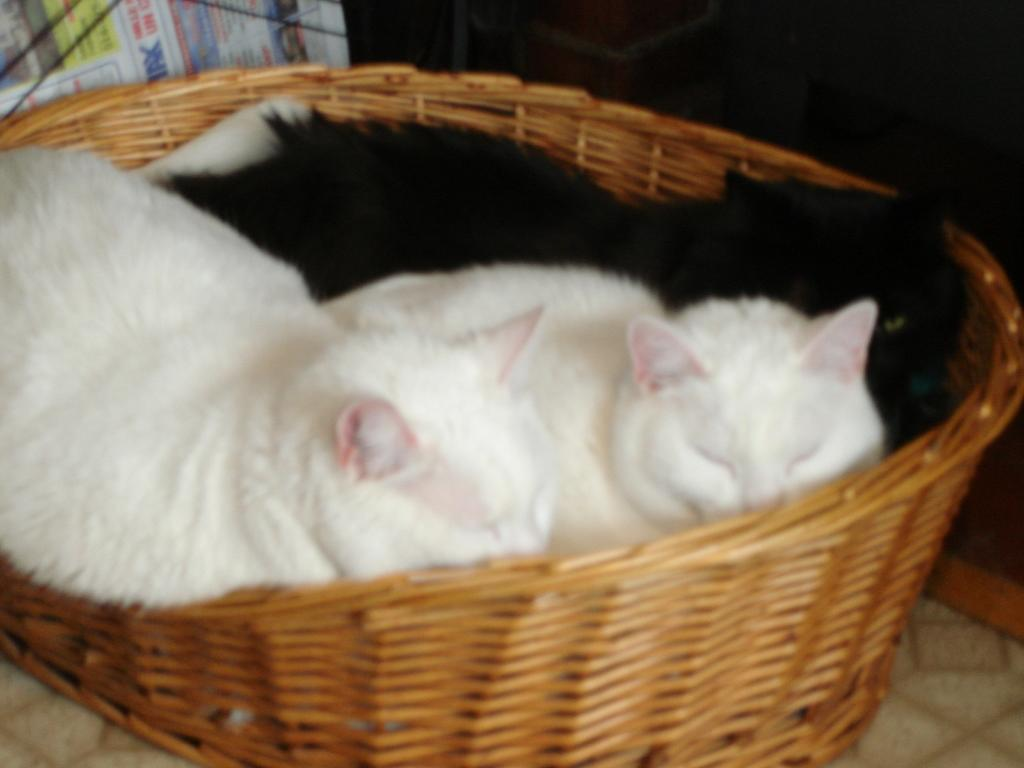How many cats are in the image? There are three cats in the image. Where are the cats located? The cats are in a basket. What is the basket placed on? The basket is placed on a surface. What else can be seen in the image besides the cats and the basket? There is a newspaper in the image. What type of trees can be seen in the image? There are no trees present in the image. Can you hear the cats crying in the image? The image is silent, and there is no indication of any sound, including the cats crying. 